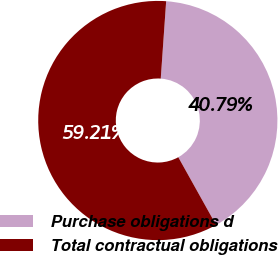Convert chart to OTSL. <chart><loc_0><loc_0><loc_500><loc_500><pie_chart><fcel>Purchase obligations d<fcel>Total contractual obligations<nl><fcel>40.79%<fcel>59.21%<nl></chart> 